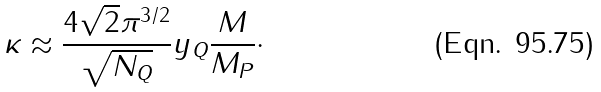Convert formula to latex. <formula><loc_0><loc_0><loc_500><loc_500>\kappa \approx \frac { 4 \sqrt { 2 } \pi ^ { 3 / 2 } } { \sqrt { N _ { Q } } } y _ { Q } \frac { M } { M _ { P } } \cdot</formula> 